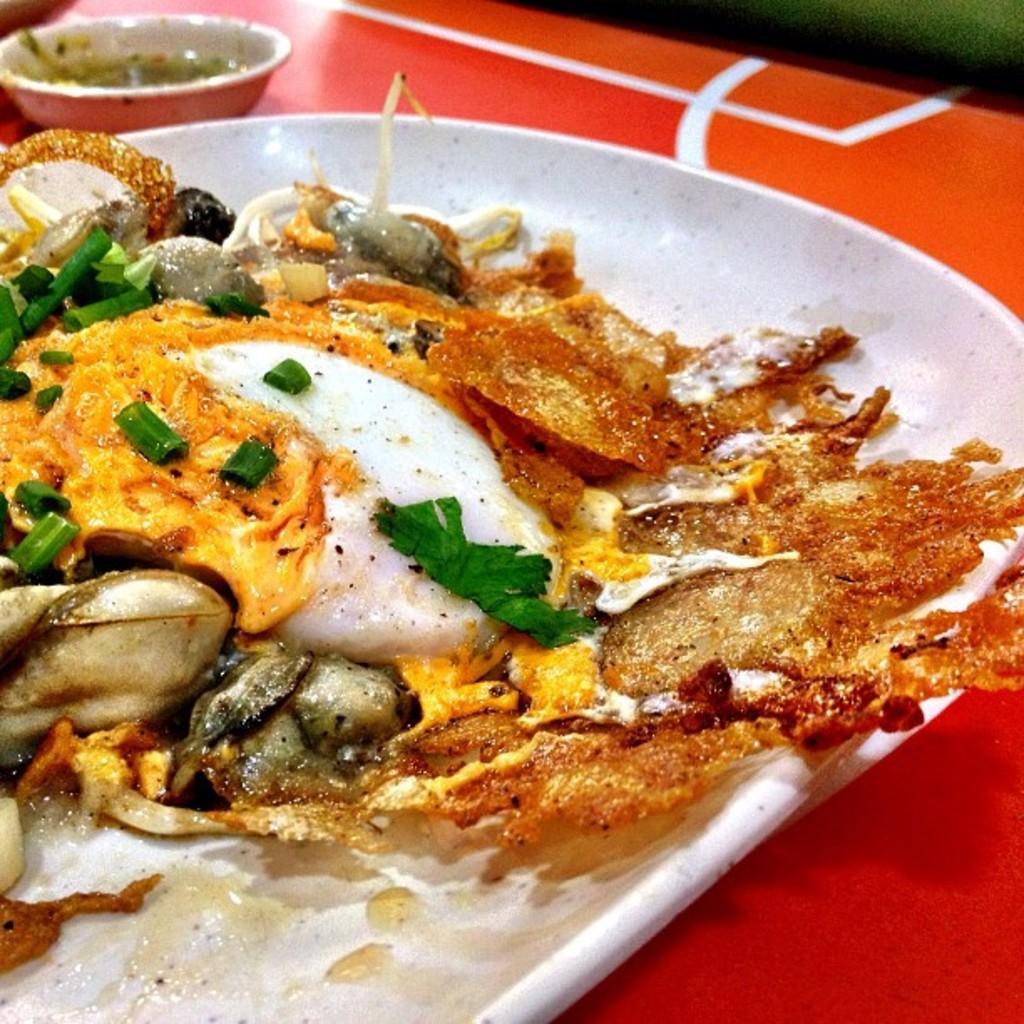How would you summarize this image in a sentence or two? In the image we can see there is a food item in a plate kept on the table and in a bowl there is sauce. 